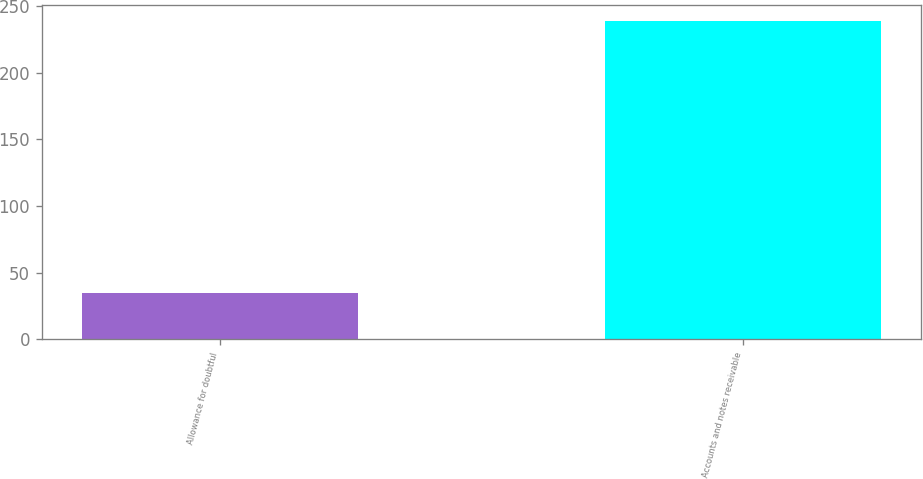Convert chart to OTSL. <chart><loc_0><loc_0><loc_500><loc_500><bar_chart><fcel>Allowance for doubtful<fcel>Accounts and notes receivable<nl><fcel>35<fcel>239<nl></chart> 